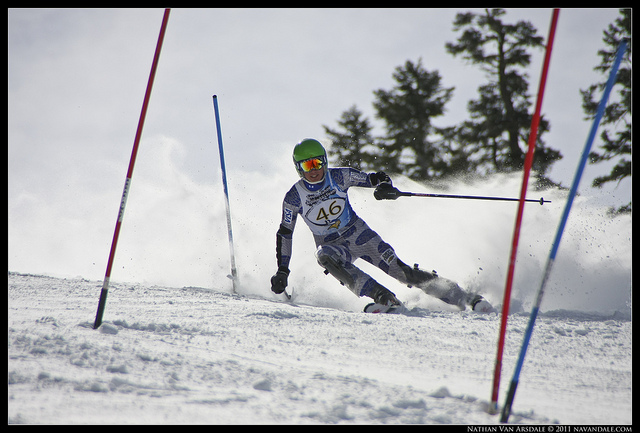Please extract the text content from this image. 46 2011 VAN 